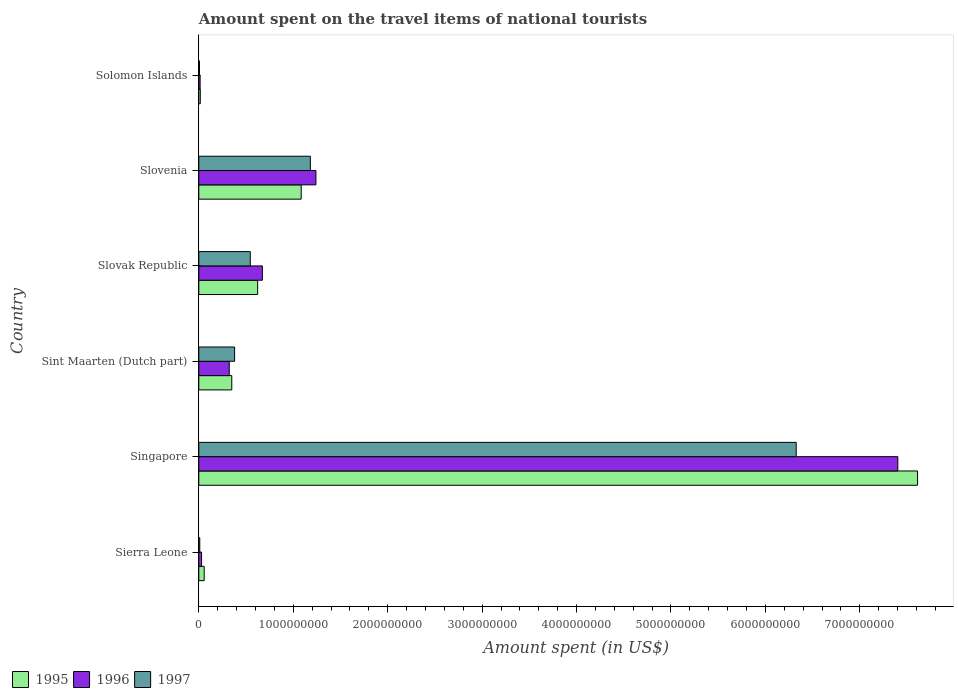Are the number of bars per tick equal to the number of legend labels?
Give a very brief answer. Yes. Are the number of bars on each tick of the Y-axis equal?
Keep it short and to the point. Yes. How many bars are there on the 4th tick from the top?
Keep it short and to the point. 3. How many bars are there on the 6th tick from the bottom?
Give a very brief answer. 3. What is the label of the 4th group of bars from the top?
Keep it short and to the point. Sint Maarten (Dutch part). In how many cases, is the number of bars for a given country not equal to the number of legend labels?
Your response must be concise. 0. What is the amount spent on the travel items of national tourists in 1996 in Sierra Leone?
Your response must be concise. 2.90e+07. Across all countries, what is the maximum amount spent on the travel items of national tourists in 1995?
Keep it short and to the point. 7.61e+09. Across all countries, what is the minimum amount spent on the travel items of national tourists in 1997?
Offer a terse response. 7.10e+06. In which country was the amount spent on the travel items of national tourists in 1997 maximum?
Your answer should be compact. Singapore. In which country was the amount spent on the travel items of national tourists in 1996 minimum?
Provide a succinct answer. Solomon Islands. What is the total amount spent on the travel items of national tourists in 1995 in the graph?
Ensure brevity in your answer.  9.74e+09. What is the difference between the amount spent on the travel items of national tourists in 1996 in Sierra Leone and that in Singapore?
Offer a very short reply. -7.37e+09. What is the difference between the amount spent on the travel items of national tourists in 1996 in Sierra Leone and the amount spent on the travel items of national tourists in 1995 in Sint Maarten (Dutch part)?
Keep it short and to the point. -3.20e+08. What is the average amount spent on the travel items of national tourists in 1995 per country?
Offer a very short reply. 1.62e+09. What is the difference between the amount spent on the travel items of national tourists in 1996 and amount spent on the travel items of national tourists in 1997 in Slovenia?
Your response must be concise. 5.90e+07. What is the ratio of the amount spent on the travel items of national tourists in 1995 in Slovak Republic to that in Solomon Islands?
Provide a short and direct response. 39.68. What is the difference between the highest and the second highest amount spent on the travel items of national tourists in 1995?
Your answer should be very brief. 6.53e+09. What is the difference between the highest and the lowest amount spent on the travel items of national tourists in 1995?
Make the answer very short. 7.60e+09. What does the 3rd bar from the top in Solomon Islands represents?
Offer a very short reply. 1995. How many bars are there?
Offer a terse response. 18. Are all the bars in the graph horizontal?
Keep it short and to the point. Yes. Where does the legend appear in the graph?
Offer a terse response. Bottom left. How many legend labels are there?
Your answer should be very brief. 3. What is the title of the graph?
Offer a terse response. Amount spent on the travel items of national tourists. Does "1967" appear as one of the legend labels in the graph?
Your answer should be very brief. No. What is the label or title of the X-axis?
Your response must be concise. Amount spent (in US$). What is the label or title of the Y-axis?
Provide a succinct answer. Country. What is the Amount spent (in US$) in 1995 in Sierra Leone?
Provide a short and direct response. 5.70e+07. What is the Amount spent (in US$) in 1996 in Sierra Leone?
Offer a very short reply. 2.90e+07. What is the Amount spent (in US$) of 1997 in Sierra Leone?
Give a very brief answer. 1.00e+07. What is the Amount spent (in US$) of 1995 in Singapore?
Ensure brevity in your answer.  7.61e+09. What is the Amount spent (in US$) in 1996 in Singapore?
Your answer should be compact. 7.40e+09. What is the Amount spent (in US$) in 1997 in Singapore?
Keep it short and to the point. 6.33e+09. What is the Amount spent (in US$) in 1995 in Sint Maarten (Dutch part)?
Keep it short and to the point. 3.49e+08. What is the Amount spent (in US$) in 1996 in Sint Maarten (Dutch part)?
Offer a terse response. 3.22e+08. What is the Amount spent (in US$) of 1997 in Sint Maarten (Dutch part)?
Ensure brevity in your answer.  3.79e+08. What is the Amount spent (in US$) in 1995 in Slovak Republic?
Make the answer very short. 6.23e+08. What is the Amount spent (in US$) in 1996 in Slovak Republic?
Offer a terse response. 6.73e+08. What is the Amount spent (in US$) in 1997 in Slovak Republic?
Give a very brief answer. 5.45e+08. What is the Amount spent (in US$) of 1995 in Slovenia?
Provide a short and direct response. 1.08e+09. What is the Amount spent (in US$) in 1996 in Slovenia?
Provide a succinct answer. 1.24e+09. What is the Amount spent (in US$) of 1997 in Slovenia?
Offer a terse response. 1.18e+09. What is the Amount spent (in US$) of 1995 in Solomon Islands?
Offer a very short reply. 1.57e+07. What is the Amount spent (in US$) in 1996 in Solomon Islands?
Your response must be concise. 1.39e+07. What is the Amount spent (in US$) of 1997 in Solomon Islands?
Give a very brief answer. 7.10e+06. Across all countries, what is the maximum Amount spent (in US$) of 1995?
Make the answer very short. 7.61e+09. Across all countries, what is the maximum Amount spent (in US$) in 1996?
Offer a terse response. 7.40e+09. Across all countries, what is the maximum Amount spent (in US$) of 1997?
Ensure brevity in your answer.  6.33e+09. Across all countries, what is the minimum Amount spent (in US$) of 1995?
Ensure brevity in your answer.  1.57e+07. Across all countries, what is the minimum Amount spent (in US$) of 1996?
Offer a very short reply. 1.39e+07. Across all countries, what is the minimum Amount spent (in US$) in 1997?
Provide a succinct answer. 7.10e+06. What is the total Amount spent (in US$) of 1995 in the graph?
Provide a short and direct response. 9.74e+09. What is the total Amount spent (in US$) of 1996 in the graph?
Provide a short and direct response. 9.68e+09. What is the total Amount spent (in US$) in 1997 in the graph?
Your answer should be compact. 8.45e+09. What is the difference between the Amount spent (in US$) of 1995 in Sierra Leone and that in Singapore?
Offer a terse response. -7.55e+09. What is the difference between the Amount spent (in US$) of 1996 in Sierra Leone and that in Singapore?
Offer a terse response. -7.37e+09. What is the difference between the Amount spent (in US$) in 1997 in Sierra Leone and that in Singapore?
Your answer should be compact. -6.32e+09. What is the difference between the Amount spent (in US$) in 1995 in Sierra Leone and that in Sint Maarten (Dutch part)?
Offer a terse response. -2.92e+08. What is the difference between the Amount spent (in US$) in 1996 in Sierra Leone and that in Sint Maarten (Dutch part)?
Ensure brevity in your answer.  -2.93e+08. What is the difference between the Amount spent (in US$) in 1997 in Sierra Leone and that in Sint Maarten (Dutch part)?
Offer a very short reply. -3.69e+08. What is the difference between the Amount spent (in US$) in 1995 in Sierra Leone and that in Slovak Republic?
Keep it short and to the point. -5.66e+08. What is the difference between the Amount spent (in US$) of 1996 in Sierra Leone and that in Slovak Republic?
Your answer should be compact. -6.44e+08. What is the difference between the Amount spent (in US$) in 1997 in Sierra Leone and that in Slovak Republic?
Offer a very short reply. -5.35e+08. What is the difference between the Amount spent (in US$) in 1995 in Sierra Leone and that in Slovenia?
Your answer should be very brief. -1.03e+09. What is the difference between the Amount spent (in US$) of 1996 in Sierra Leone and that in Slovenia?
Keep it short and to the point. -1.21e+09. What is the difference between the Amount spent (in US$) of 1997 in Sierra Leone and that in Slovenia?
Provide a succinct answer. -1.17e+09. What is the difference between the Amount spent (in US$) in 1995 in Sierra Leone and that in Solomon Islands?
Offer a terse response. 4.13e+07. What is the difference between the Amount spent (in US$) in 1996 in Sierra Leone and that in Solomon Islands?
Ensure brevity in your answer.  1.51e+07. What is the difference between the Amount spent (in US$) in 1997 in Sierra Leone and that in Solomon Islands?
Offer a terse response. 2.90e+06. What is the difference between the Amount spent (in US$) of 1995 in Singapore and that in Sint Maarten (Dutch part)?
Give a very brief answer. 7.26e+09. What is the difference between the Amount spent (in US$) in 1996 in Singapore and that in Sint Maarten (Dutch part)?
Ensure brevity in your answer.  7.08e+09. What is the difference between the Amount spent (in US$) in 1997 in Singapore and that in Sint Maarten (Dutch part)?
Ensure brevity in your answer.  5.95e+09. What is the difference between the Amount spent (in US$) in 1995 in Singapore and that in Slovak Republic?
Ensure brevity in your answer.  6.99e+09. What is the difference between the Amount spent (in US$) of 1996 in Singapore and that in Slovak Republic?
Ensure brevity in your answer.  6.73e+09. What is the difference between the Amount spent (in US$) of 1997 in Singapore and that in Slovak Republic?
Offer a very short reply. 5.78e+09. What is the difference between the Amount spent (in US$) of 1995 in Singapore and that in Slovenia?
Your answer should be very brief. 6.53e+09. What is the difference between the Amount spent (in US$) in 1996 in Singapore and that in Slovenia?
Make the answer very short. 6.16e+09. What is the difference between the Amount spent (in US$) of 1997 in Singapore and that in Slovenia?
Your response must be concise. 5.14e+09. What is the difference between the Amount spent (in US$) of 1995 in Singapore and that in Solomon Islands?
Your response must be concise. 7.60e+09. What is the difference between the Amount spent (in US$) of 1996 in Singapore and that in Solomon Islands?
Keep it short and to the point. 7.39e+09. What is the difference between the Amount spent (in US$) in 1997 in Singapore and that in Solomon Islands?
Give a very brief answer. 6.32e+09. What is the difference between the Amount spent (in US$) in 1995 in Sint Maarten (Dutch part) and that in Slovak Republic?
Offer a very short reply. -2.74e+08. What is the difference between the Amount spent (in US$) of 1996 in Sint Maarten (Dutch part) and that in Slovak Republic?
Your answer should be very brief. -3.51e+08. What is the difference between the Amount spent (in US$) in 1997 in Sint Maarten (Dutch part) and that in Slovak Republic?
Offer a terse response. -1.66e+08. What is the difference between the Amount spent (in US$) in 1995 in Sint Maarten (Dutch part) and that in Slovenia?
Your answer should be very brief. -7.35e+08. What is the difference between the Amount spent (in US$) of 1996 in Sint Maarten (Dutch part) and that in Slovenia?
Make the answer very short. -9.18e+08. What is the difference between the Amount spent (in US$) of 1997 in Sint Maarten (Dutch part) and that in Slovenia?
Provide a short and direct response. -8.02e+08. What is the difference between the Amount spent (in US$) of 1995 in Sint Maarten (Dutch part) and that in Solomon Islands?
Offer a very short reply. 3.33e+08. What is the difference between the Amount spent (in US$) in 1996 in Sint Maarten (Dutch part) and that in Solomon Islands?
Your response must be concise. 3.08e+08. What is the difference between the Amount spent (in US$) in 1997 in Sint Maarten (Dutch part) and that in Solomon Islands?
Offer a terse response. 3.72e+08. What is the difference between the Amount spent (in US$) in 1995 in Slovak Republic and that in Slovenia?
Offer a terse response. -4.61e+08. What is the difference between the Amount spent (in US$) in 1996 in Slovak Republic and that in Slovenia?
Offer a very short reply. -5.67e+08. What is the difference between the Amount spent (in US$) of 1997 in Slovak Republic and that in Slovenia?
Your response must be concise. -6.36e+08. What is the difference between the Amount spent (in US$) in 1995 in Slovak Republic and that in Solomon Islands?
Ensure brevity in your answer.  6.07e+08. What is the difference between the Amount spent (in US$) in 1996 in Slovak Republic and that in Solomon Islands?
Make the answer very short. 6.59e+08. What is the difference between the Amount spent (in US$) of 1997 in Slovak Republic and that in Solomon Islands?
Keep it short and to the point. 5.38e+08. What is the difference between the Amount spent (in US$) in 1995 in Slovenia and that in Solomon Islands?
Offer a very short reply. 1.07e+09. What is the difference between the Amount spent (in US$) of 1996 in Slovenia and that in Solomon Islands?
Your answer should be compact. 1.23e+09. What is the difference between the Amount spent (in US$) of 1997 in Slovenia and that in Solomon Islands?
Offer a terse response. 1.17e+09. What is the difference between the Amount spent (in US$) of 1995 in Sierra Leone and the Amount spent (in US$) of 1996 in Singapore?
Offer a very short reply. -7.34e+09. What is the difference between the Amount spent (in US$) in 1995 in Sierra Leone and the Amount spent (in US$) in 1997 in Singapore?
Offer a very short reply. -6.27e+09. What is the difference between the Amount spent (in US$) in 1996 in Sierra Leone and the Amount spent (in US$) in 1997 in Singapore?
Your response must be concise. -6.30e+09. What is the difference between the Amount spent (in US$) in 1995 in Sierra Leone and the Amount spent (in US$) in 1996 in Sint Maarten (Dutch part)?
Your response must be concise. -2.65e+08. What is the difference between the Amount spent (in US$) in 1995 in Sierra Leone and the Amount spent (in US$) in 1997 in Sint Maarten (Dutch part)?
Offer a terse response. -3.22e+08. What is the difference between the Amount spent (in US$) in 1996 in Sierra Leone and the Amount spent (in US$) in 1997 in Sint Maarten (Dutch part)?
Ensure brevity in your answer.  -3.50e+08. What is the difference between the Amount spent (in US$) in 1995 in Sierra Leone and the Amount spent (in US$) in 1996 in Slovak Republic?
Ensure brevity in your answer.  -6.16e+08. What is the difference between the Amount spent (in US$) of 1995 in Sierra Leone and the Amount spent (in US$) of 1997 in Slovak Republic?
Keep it short and to the point. -4.88e+08. What is the difference between the Amount spent (in US$) in 1996 in Sierra Leone and the Amount spent (in US$) in 1997 in Slovak Republic?
Offer a terse response. -5.16e+08. What is the difference between the Amount spent (in US$) of 1995 in Sierra Leone and the Amount spent (in US$) of 1996 in Slovenia?
Give a very brief answer. -1.18e+09. What is the difference between the Amount spent (in US$) in 1995 in Sierra Leone and the Amount spent (in US$) in 1997 in Slovenia?
Make the answer very short. -1.12e+09. What is the difference between the Amount spent (in US$) of 1996 in Sierra Leone and the Amount spent (in US$) of 1997 in Slovenia?
Make the answer very short. -1.15e+09. What is the difference between the Amount spent (in US$) in 1995 in Sierra Leone and the Amount spent (in US$) in 1996 in Solomon Islands?
Your response must be concise. 4.31e+07. What is the difference between the Amount spent (in US$) of 1995 in Sierra Leone and the Amount spent (in US$) of 1997 in Solomon Islands?
Your answer should be very brief. 4.99e+07. What is the difference between the Amount spent (in US$) in 1996 in Sierra Leone and the Amount spent (in US$) in 1997 in Solomon Islands?
Offer a very short reply. 2.19e+07. What is the difference between the Amount spent (in US$) in 1995 in Singapore and the Amount spent (in US$) in 1996 in Sint Maarten (Dutch part)?
Make the answer very short. 7.29e+09. What is the difference between the Amount spent (in US$) of 1995 in Singapore and the Amount spent (in US$) of 1997 in Sint Maarten (Dutch part)?
Make the answer very short. 7.23e+09. What is the difference between the Amount spent (in US$) in 1996 in Singapore and the Amount spent (in US$) in 1997 in Sint Maarten (Dutch part)?
Provide a succinct answer. 7.02e+09. What is the difference between the Amount spent (in US$) in 1995 in Singapore and the Amount spent (in US$) in 1996 in Slovak Republic?
Give a very brief answer. 6.94e+09. What is the difference between the Amount spent (in US$) of 1995 in Singapore and the Amount spent (in US$) of 1997 in Slovak Republic?
Give a very brief answer. 7.07e+09. What is the difference between the Amount spent (in US$) of 1996 in Singapore and the Amount spent (in US$) of 1997 in Slovak Republic?
Make the answer very short. 6.86e+09. What is the difference between the Amount spent (in US$) in 1995 in Singapore and the Amount spent (in US$) in 1996 in Slovenia?
Ensure brevity in your answer.  6.37e+09. What is the difference between the Amount spent (in US$) of 1995 in Singapore and the Amount spent (in US$) of 1997 in Slovenia?
Give a very brief answer. 6.43e+09. What is the difference between the Amount spent (in US$) in 1996 in Singapore and the Amount spent (in US$) in 1997 in Slovenia?
Your answer should be very brief. 6.22e+09. What is the difference between the Amount spent (in US$) in 1995 in Singapore and the Amount spent (in US$) in 1996 in Solomon Islands?
Your answer should be very brief. 7.60e+09. What is the difference between the Amount spent (in US$) in 1995 in Singapore and the Amount spent (in US$) in 1997 in Solomon Islands?
Offer a very short reply. 7.60e+09. What is the difference between the Amount spent (in US$) in 1996 in Singapore and the Amount spent (in US$) in 1997 in Solomon Islands?
Make the answer very short. 7.39e+09. What is the difference between the Amount spent (in US$) of 1995 in Sint Maarten (Dutch part) and the Amount spent (in US$) of 1996 in Slovak Republic?
Your answer should be very brief. -3.24e+08. What is the difference between the Amount spent (in US$) in 1995 in Sint Maarten (Dutch part) and the Amount spent (in US$) in 1997 in Slovak Republic?
Your response must be concise. -1.96e+08. What is the difference between the Amount spent (in US$) of 1996 in Sint Maarten (Dutch part) and the Amount spent (in US$) of 1997 in Slovak Republic?
Keep it short and to the point. -2.23e+08. What is the difference between the Amount spent (in US$) of 1995 in Sint Maarten (Dutch part) and the Amount spent (in US$) of 1996 in Slovenia?
Make the answer very short. -8.91e+08. What is the difference between the Amount spent (in US$) in 1995 in Sint Maarten (Dutch part) and the Amount spent (in US$) in 1997 in Slovenia?
Offer a terse response. -8.32e+08. What is the difference between the Amount spent (in US$) in 1996 in Sint Maarten (Dutch part) and the Amount spent (in US$) in 1997 in Slovenia?
Provide a succinct answer. -8.59e+08. What is the difference between the Amount spent (in US$) of 1995 in Sint Maarten (Dutch part) and the Amount spent (in US$) of 1996 in Solomon Islands?
Your response must be concise. 3.35e+08. What is the difference between the Amount spent (in US$) in 1995 in Sint Maarten (Dutch part) and the Amount spent (in US$) in 1997 in Solomon Islands?
Provide a short and direct response. 3.42e+08. What is the difference between the Amount spent (in US$) of 1996 in Sint Maarten (Dutch part) and the Amount spent (in US$) of 1997 in Solomon Islands?
Offer a terse response. 3.15e+08. What is the difference between the Amount spent (in US$) in 1995 in Slovak Republic and the Amount spent (in US$) in 1996 in Slovenia?
Your response must be concise. -6.17e+08. What is the difference between the Amount spent (in US$) of 1995 in Slovak Republic and the Amount spent (in US$) of 1997 in Slovenia?
Offer a very short reply. -5.58e+08. What is the difference between the Amount spent (in US$) in 1996 in Slovak Republic and the Amount spent (in US$) in 1997 in Slovenia?
Offer a very short reply. -5.08e+08. What is the difference between the Amount spent (in US$) in 1995 in Slovak Republic and the Amount spent (in US$) in 1996 in Solomon Islands?
Provide a short and direct response. 6.09e+08. What is the difference between the Amount spent (in US$) in 1995 in Slovak Republic and the Amount spent (in US$) in 1997 in Solomon Islands?
Your answer should be very brief. 6.16e+08. What is the difference between the Amount spent (in US$) in 1996 in Slovak Republic and the Amount spent (in US$) in 1997 in Solomon Islands?
Offer a terse response. 6.66e+08. What is the difference between the Amount spent (in US$) in 1995 in Slovenia and the Amount spent (in US$) in 1996 in Solomon Islands?
Give a very brief answer. 1.07e+09. What is the difference between the Amount spent (in US$) in 1995 in Slovenia and the Amount spent (in US$) in 1997 in Solomon Islands?
Provide a succinct answer. 1.08e+09. What is the difference between the Amount spent (in US$) in 1996 in Slovenia and the Amount spent (in US$) in 1997 in Solomon Islands?
Your answer should be very brief. 1.23e+09. What is the average Amount spent (in US$) in 1995 per country?
Give a very brief answer. 1.62e+09. What is the average Amount spent (in US$) in 1996 per country?
Your answer should be compact. 1.61e+09. What is the average Amount spent (in US$) in 1997 per country?
Your response must be concise. 1.41e+09. What is the difference between the Amount spent (in US$) in 1995 and Amount spent (in US$) in 1996 in Sierra Leone?
Your answer should be very brief. 2.80e+07. What is the difference between the Amount spent (in US$) in 1995 and Amount spent (in US$) in 1997 in Sierra Leone?
Ensure brevity in your answer.  4.70e+07. What is the difference between the Amount spent (in US$) in 1996 and Amount spent (in US$) in 1997 in Sierra Leone?
Your answer should be very brief. 1.90e+07. What is the difference between the Amount spent (in US$) in 1995 and Amount spent (in US$) in 1996 in Singapore?
Offer a very short reply. 2.09e+08. What is the difference between the Amount spent (in US$) of 1995 and Amount spent (in US$) of 1997 in Singapore?
Offer a terse response. 1.28e+09. What is the difference between the Amount spent (in US$) in 1996 and Amount spent (in US$) in 1997 in Singapore?
Your answer should be very brief. 1.08e+09. What is the difference between the Amount spent (in US$) of 1995 and Amount spent (in US$) of 1996 in Sint Maarten (Dutch part)?
Offer a terse response. 2.70e+07. What is the difference between the Amount spent (in US$) in 1995 and Amount spent (in US$) in 1997 in Sint Maarten (Dutch part)?
Your response must be concise. -3.00e+07. What is the difference between the Amount spent (in US$) of 1996 and Amount spent (in US$) of 1997 in Sint Maarten (Dutch part)?
Give a very brief answer. -5.70e+07. What is the difference between the Amount spent (in US$) in 1995 and Amount spent (in US$) in 1996 in Slovak Republic?
Provide a short and direct response. -5.00e+07. What is the difference between the Amount spent (in US$) of 1995 and Amount spent (in US$) of 1997 in Slovak Republic?
Ensure brevity in your answer.  7.80e+07. What is the difference between the Amount spent (in US$) in 1996 and Amount spent (in US$) in 1997 in Slovak Republic?
Your answer should be compact. 1.28e+08. What is the difference between the Amount spent (in US$) in 1995 and Amount spent (in US$) in 1996 in Slovenia?
Ensure brevity in your answer.  -1.56e+08. What is the difference between the Amount spent (in US$) of 1995 and Amount spent (in US$) of 1997 in Slovenia?
Provide a short and direct response. -9.70e+07. What is the difference between the Amount spent (in US$) in 1996 and Amount spent (in US$) in 1997 in Slovenia?
Your answer should be very brief. 5.90e+07. What is the difference between the Amount spent (in US$) in 1995 and Amount spent (in US$) in 1996 in Solomon Islands?
Ensure brevity in your answer.  1.80e+06. What is the difference between the Amount spent (in US$) of 1995 and Amount spent (in US$) of 1997 in Solomon Islands?
Provide a short and direct response. 8.60e+06. What is the difference between the Amount spent (in US$) of 1996 and Amount spent (in US$) of 1997 in Solomon Islands?
Keep it short and to the point. 6.80e+06. What is the ratio of the Amount spent (in US$) of 1995 in Sierra Leone to that in Singapore?
Ensure brevity in your answer.  0.01. What is the ratio of the Amount spent (in US$) in 1996 in Sierra Leone to that in Singapore?
Give a very brief answer. 0. What is the ratio of the Amount spent (in US$) in 1997 in Sierra Leone to that in Singapore?
Keep it short and to the point. 0. What is the ratio of the Amount spent (in US$) of 1995 in Sierra Leone to that in Sint Maarten (Dutch part)?
Your answer should be compact. 0.16. What is the ratio of the Amount spent (in US$) of 1996 in Sierra Leone to that in Sint Maarten (Dutch part)?
Ensure brevity in your answer.  0.09. What is the ratio of the Amount spent (in US$) in 1997 in Sierra Leone to that in Sint Maarten (Dutch part)?
Your response must be concise. 0.03. What is the ratio of the Amount spent (in US$) in 1995 in Sierra Leone to that in Slovak Republic?
Your answer should be very brief. 0.09. What is the ratio of the Amount spent (in US$) in 1996 in Sierra Leone to that in Slovak Republic?
Ensure brevity in your answer.  0.04. What is the ratio of the Amount spent (in US$) in 1997 in Sierra Leone to that in Slovak Republic?
Your response must be concise. 0.02. What is the ratio of the Amount spent (in US$) of 1995 in Sierra Leone to that in Slovenia?
Offer a very short reply. 0.05. What is the ratio of the Amount spent (in US$) of 1996 in Sierra Leone to that in Slovenia?
Offer a terse response. 0.02. What is the ratio of the Amount spent (in US$) in 1997 in Sierra Leone to that in Slovenia?
Your answer should be very brief. 0.01. What is the ratio of the Amount spent (in US$) of 1995 in Sierra Leone to that in Solomon Islands?
Make the answer very short. 3.63. What is the ratio of the Amount spent (in US$) of 1996 in Sierra Leone to that in Solomon Islands?
Offer a terse response. 2.09. What is the ratio of the Amount spent (in US$) in 1997 in Sierra Leone to that in Solomon Islands?
Offer a terse response. 1.41. What is the ratio of the Amount spent (in US$) in 1995 in Singapore to that in Sint Maarten (Dutch part)?
Give a very brief answer. 21.81. What is the ratio of the Amount spent (in US$) of 1996 in Singapore to that in Sint Maarten (Dutch part)?
Provide a succinct answer. 22.99. What is the ratio of the Amount spent (in US$) in 1997 in Singapore to that in Sint Maarten (Dutch part)?
Make the answer very short. 16.69. What is the ratio of the Amount spent (in US$) of 1995 in Singapore to that in Slovak Republic?
Your answer should be compact. 12.22. What is the ratio of the Amount spent (in US$) in 1996 in Singapore to that in Slovak Republic?
Keep it short and to the point. 11. What is the ratio of the Amount spent (in US$) in 1997 in Singapore to that in Slovak Republic?
Keep it short and to the point. 11.61. What is the ratio of the Amount spent (in US$) in 1995 in Singapore to that in Slovenia?
Offer a terse response. 7.02. What is the ratio of the Amount spent (in US$) of 1996 in Singapore to that in Slovenia?
Provide a short and direct response. 5.97. What is the ratio of the Amount spent (in US$) of 1997 in Singapore to that in Slovenia?
Provide a short and direct response. 5.36. What is the ratio of the Amount spent (in US$) in 1995 in Singapore to that in Solomon Islands?
Ensure brevity in your answer.  484.78. What is the ratio of the Amount spent (in US$) of 1996 in Singapore to that in Solomon Islands?
Ensure brevity in your answer.  532.52. What is the ratio of the Amount spent (in US$) of 1997 in Singapore to that in Solomon Islands?
Your answer should be very brief. 890.99. What is the ratio of the Amount spent (in US$) of 1995 in Sint Maarten (Dutch part) to that in Slovak Republic?
Offer a very short reply. 0.56. What is the ratio of the Amount spent (in US$) in 1996 in Sint Maarten (Dutch part) to that in Slovak Republic?
Ensure brevity in your answer.  0.48. What is the ratio of the Amount spent (in US$) of 1997 in Sint Maarten (Dutch part) to that in Slovak Republic?
Your answer should be compact. 0.7. What is the ratio of the Amount spent (in US$) of 1995 in Sint Maarten (Dutch part) to that in Slovenia?
Provide a short and direct response. 0.32. What is the ratio of the Amount spent (in US$) of 1996 in Sint Maarten (Dutch part) to that in Slovenia?
Ensure brevity in your answer.  0.26. What is the ratio of the Amount spent (in US$) in 1997 in Sint Maarten (Dutch part) to that in Slovenia?
Provide a succinct answer. 0.32. What is the ratio of the Amount spent (in US$) in 1995 in Sint Maarten (Dutch part) to that in Solomon Islands?
Your answer should be very brief. 22.23. What is the ratio of the Amount spent (in US$) of 1996 in Sint Maarten (Dutch part) to that in Solomon Islands?
Provide a succinct answer. 23.17. What is the ratio of the Amount spent (in US$) of 1997 in Sint Maarten (Dutch part) to that in Solomon Islands?
Give a very brief answer. 53.38. What is the ratio of the Amount spent (in US$) in 1995 in Slovak Republic to that in Slovenia?
Ensure brevity in your answer.  0.57. What is the ratio of the Amount spent (in US$) in 1996 in Slovak Republic to that in Slovenia?
Offer a terse response. 0.54. What is the ratio of the Amount spent (in US$) of 1997 in Slovak Republic to that in Slovenia?
Offer a very short reply. 0.46. What is the ratio of the Amount spent (in US$) of 1995 in Slovak Republic to that in Solomon Islands?
Keep it short and to the point. 39.68. What is the ratio of the Amount spent (in US$) in 1996 in Slovak Republic to that in Solomon Islands?
Your answer should be compact. 48.42. What is the ratio of the Amount spent (in US$) in 1997 in Slovak Republic to that in Solomon Islands?
Your response must be concise. 76.76. What is the ratio of the Amount spent (in US$) of 1995 in Slovenia to that in Solomon Islands?
Make the answer very short. 69.04. What is the ratio of the Amount spent (in US$) of 1996 in Slovenia to that in Solomon Islands?
Your response must be concise. 89.21. What is the ratio of the Amount spent (in US$) of 1997 in Slovenia to that in Solomon Islands?
Offer a terse response. 166.34. What is the difference between the highest and the second highest Amount spent (in US$) of 1995?
Give a very brief answer. 6.53e+09. What is the difference between the highest and the second highest Amount spent (in US$) of 1996?
Your response must be concise. 6.16e+09. What is the difference between the highest and the second highest Amount spent (in US$) in 1997?
Give a very brief answer. 5.14e+09. What is the difference between the highest and the lowest Amount spent (in US$) in 1995?
Make the answer very short. 7.60e+09. What is the difference between the highest and the lowest Amount spent (in US$) in 1996?
Make the answer very short. 7.39e+09. What is the difference between the highest and the lowest Amount spent (in US$) in 1997?
Provide a short and direct response. 6.32e+09. 